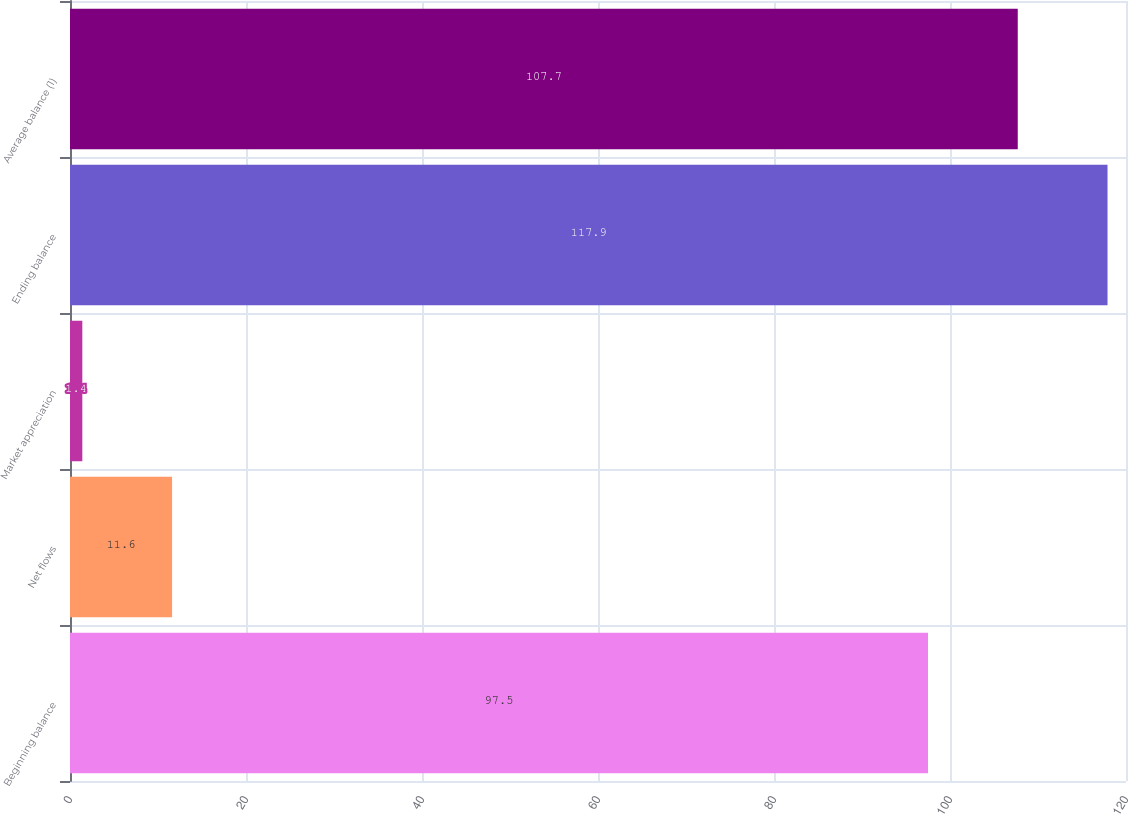Convert chart to OTSL. <chart><loc_0><loc_0><loc_500><loc_500><bar_chart><fcel>Beginning balance<fcel>Net flows<fcel>Market appreciation<fcel>Ending balance<fcel>Average balance (1)<nl><fcel>97.5<fcel>11.6<fcel>1.4<fcel>117.9<fcel>107.7<nl></chart> 